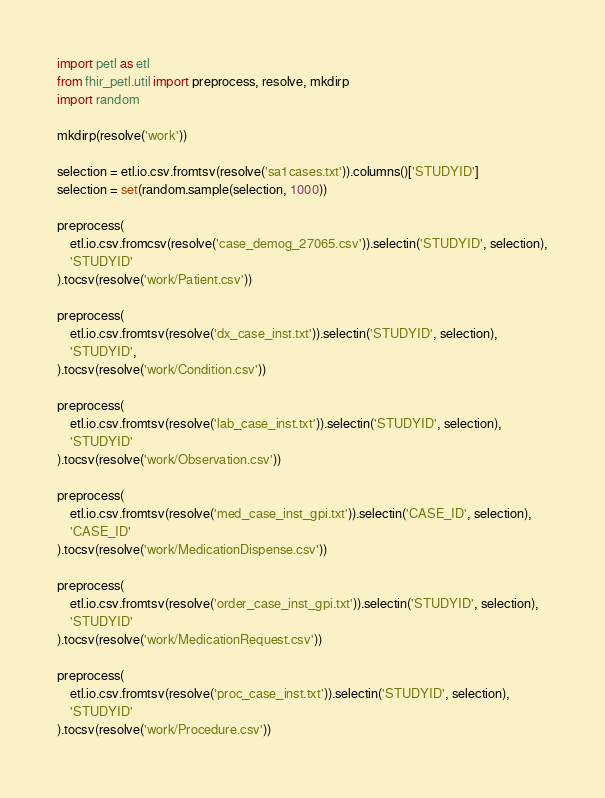<code> <loc_0><loc_0><loc_500><loc_500><_Python_>import petl as etl
from fhir_petl.util import preprocess, resolve, mkdirp
import random

mkdirp(resolve('work'))

selection = etl.io.csv.fromtsv(resolve('sa1cases.txt')).columns()['STUDYID']
selection = set(random.sample(selection, 1000))

preprocess(
    etl.io.csv.fromcsv(resolve('case_demog_27065.csv')).selectin('STUDYID', selection),
    'STUDYID'
).tocsv(resolve('work/Patient.csv'))

preprocess(
    etl.io.csv.fromtsv(resolve('dx_case_inst.txt')).selectin('STUDYID', selection),
    'STUDYID',
).tocsv(resolve('work/Condition.csv'))

preprocess(
    etl.io.csv.fromtsv(resolve('lab_case_inst.txt')).selectin('STUDYID', selection),
    'STUDYID'
).tocsv(resolve('work/Observation.csv'))

preprocess(
    etl.io.csv.fromtsv(resolve('med_case_inst_gpi.txt')).selectin('CASE_ID', selection),
    'CASE_ID'
).tocsv(resolve('work/MedicationDispense.csv'))

preprocess(
    etl.io.csv.fromtsv(resolve('order_case_inst_gpi.txt')).selectin('STUDYID', selection),
    'STUDYID'
).tocsv(resolve('work/MedicationRequest.csv'))

preprocess(
    etl.io.csv.fromtsv(resolve('proc_case_inst.txt')).selectin('STUDYID', selection),
    'STUDYID'
).tocsv(resolve('work/Procedure.csv'))
</code> 